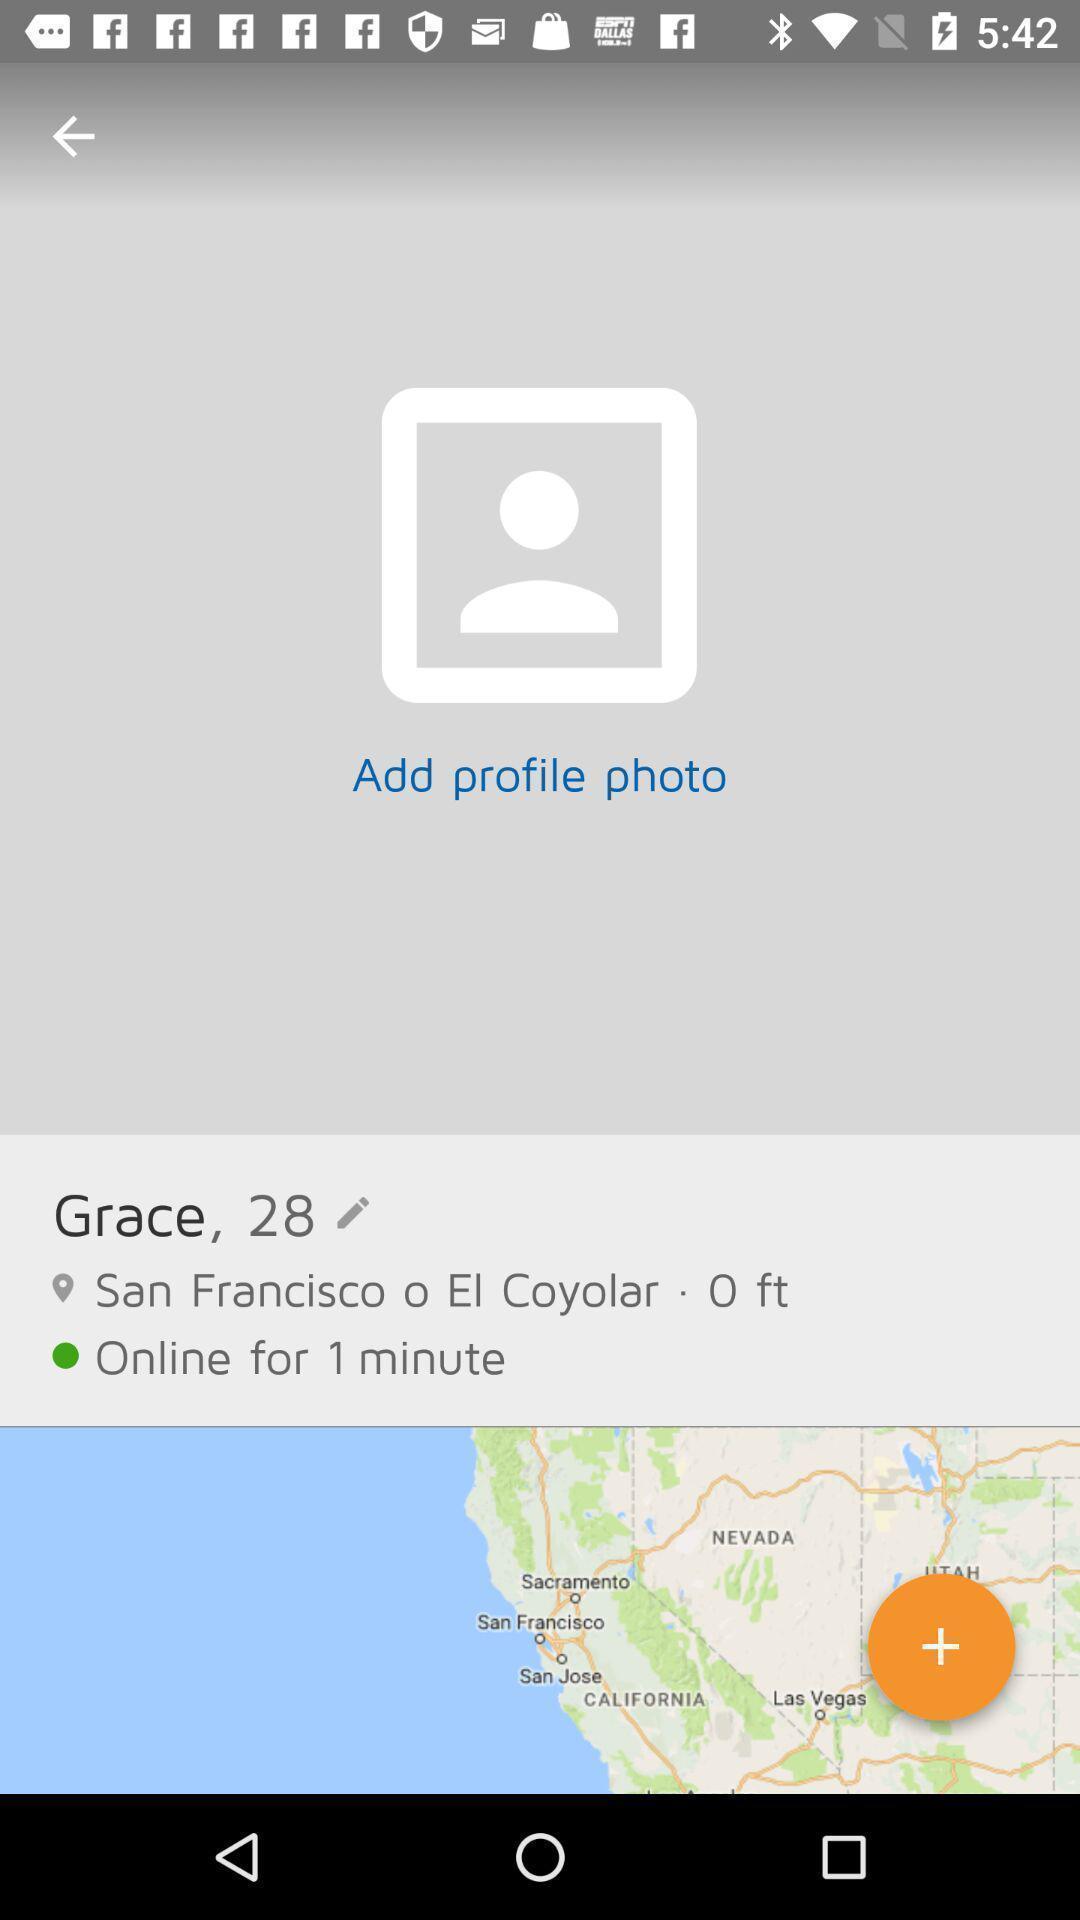Tell me what you see in this picture. Screen shows profile with map a image. 